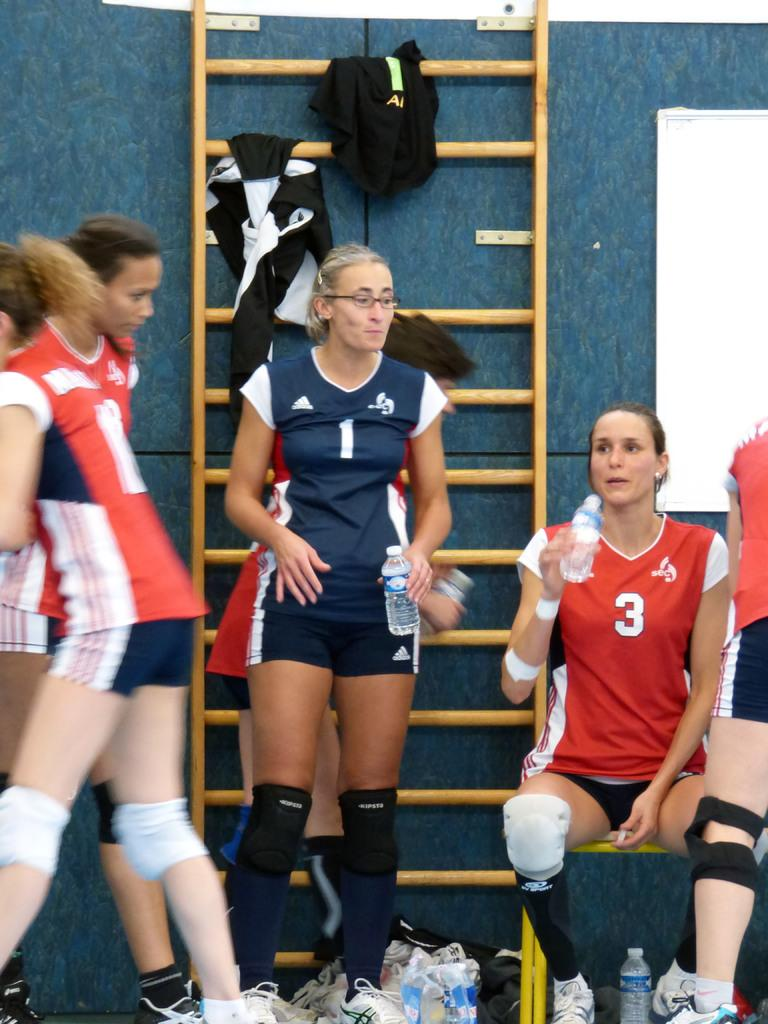<image>
Give a short and clear explanation of the subsequent image. Volleyball player wearing number 3 is drinking some water. 